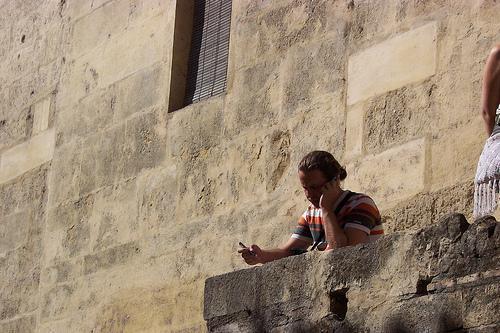How many people are seen in this photo?
Give a very brief answer. 1. 